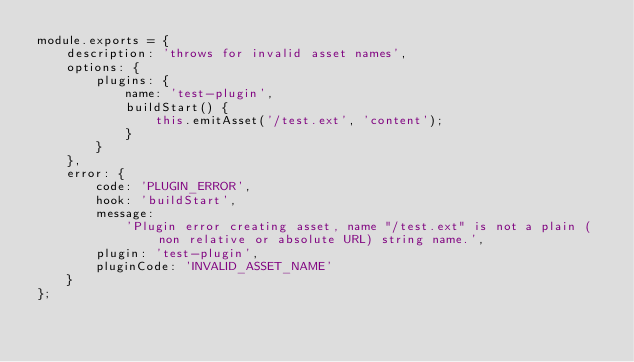<code> <loc_0><loc_0><loc_500><loc_500><_JavaScript_>module.exports = {
	description: 'throws for invalid asset names',
	options: {
		plugins: {
			name: 'test-plugin',
			buildStart() {
				this.emitAsset('/test.ext', 'content');
			}
		}
	},
	error: {
		code: 'PLUGIN_ERROR',
		hook: 'buildStart',
		message:
			'Plugin error creating asset, name "/test.ext" is not a plain (non relative or absolute URL) string name.',
		plugin: 'test-plugin',
		pluginCode: 'INVALID_ASSET_NAME'
	}
};
</code> 